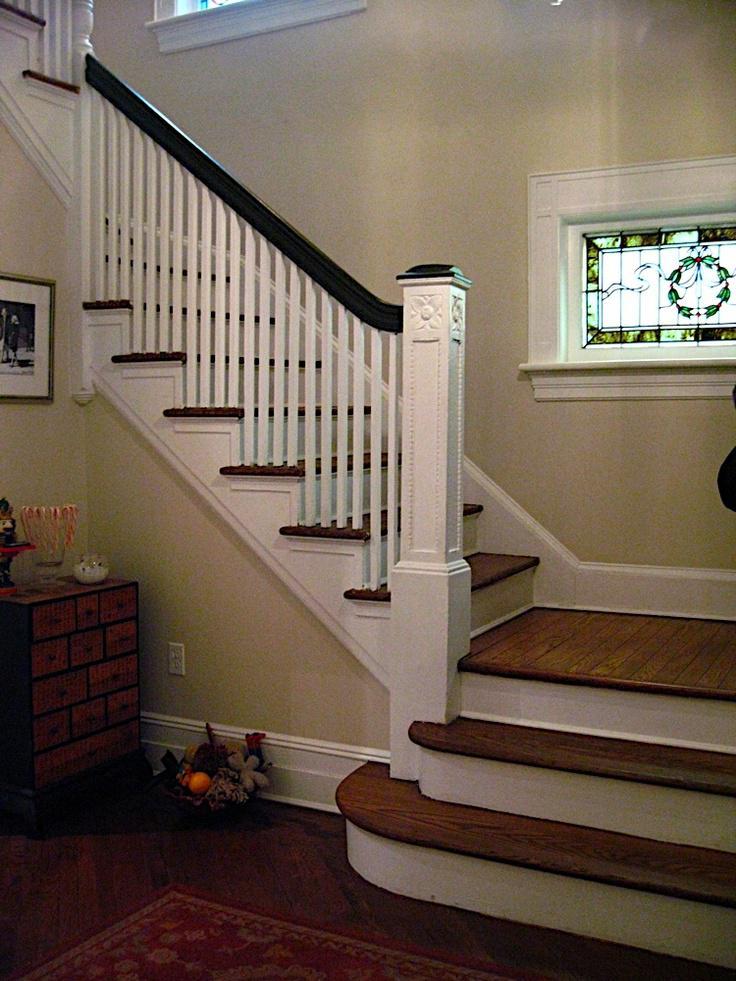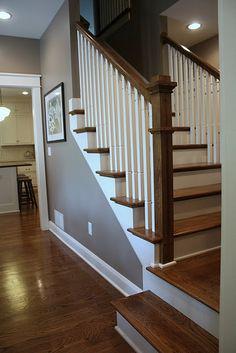The first image is the image on the left, the second image is the image on the right. Analyze the images presented: Is the assertion "The stairway in the image on the right is bordered with glass panels." valid? Answer yes or no. No. The first image is the image on the left, the second image is the image on the right. Examine the images to the left and right. Is the description "An image shows an upward view of an uncurved ascending staircase with glass panels on one side." accurate? Answer yes or no. No. 